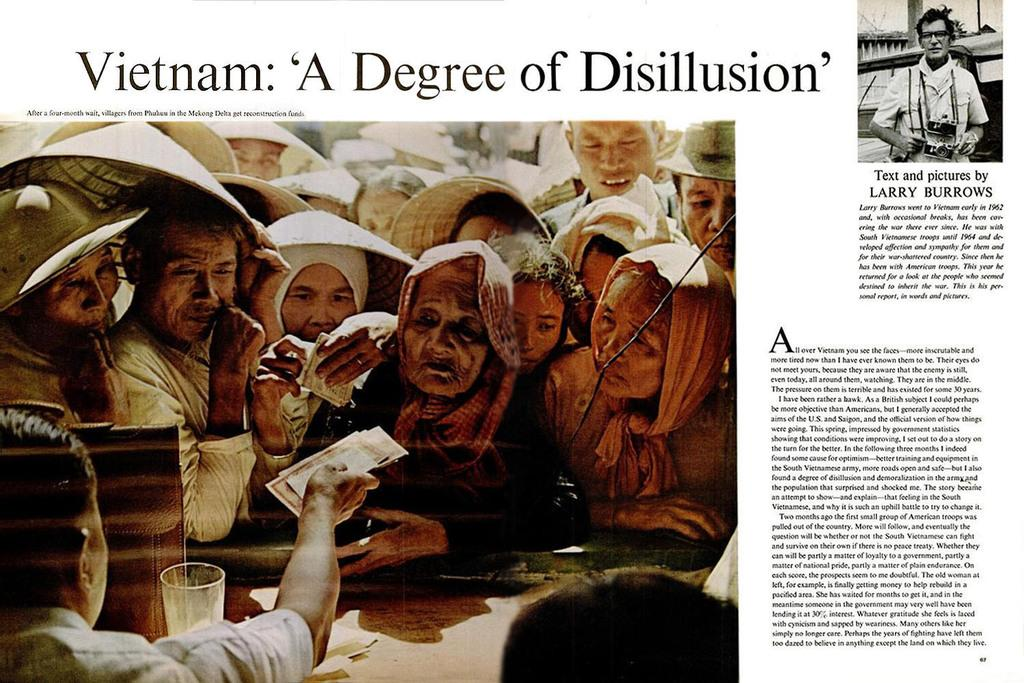What type of publication does the image appear to be? The image appears to be a magazine cover. What can be seen on the magazine cover besides text? There are images on the magazine cover. What information is conveyed through the text on the magazine cover? There is text written on the magazine cover. How many snakes are featured on the magazine cover? There are no snakes present on the magazine cover; it features images and text related to the magazine's content. 